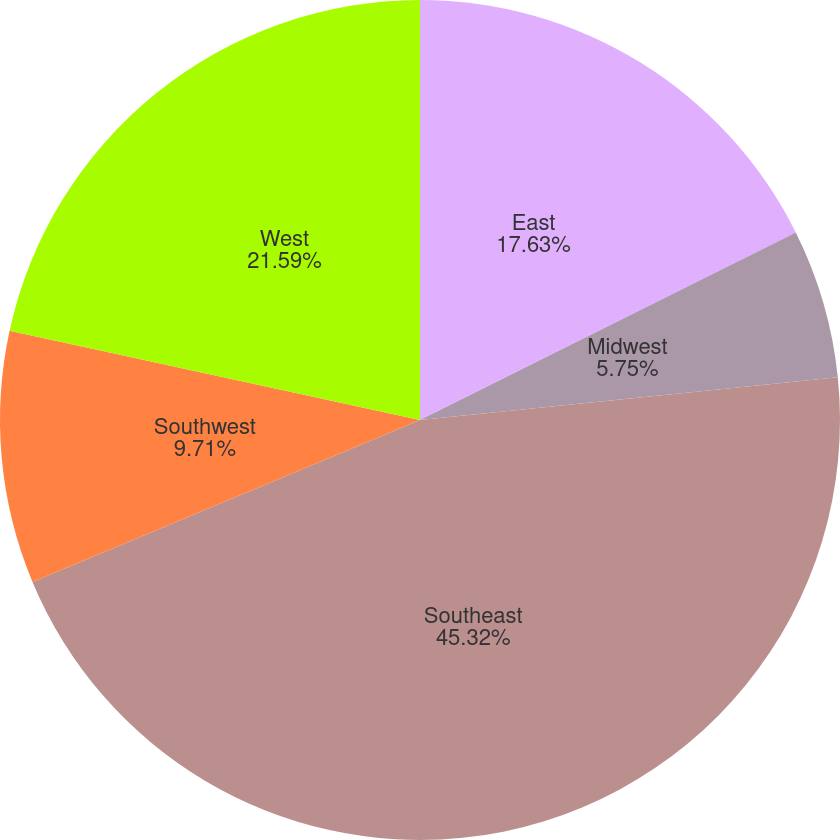<chart> <loc_0><loc_0><loc_500><loc_500><pie_chart><fcel>East<fcel>Midwest<fcel>Southeast<fcel>Southwest<fcel>West<nl><fcel>17.63%<fcel>5.75%<fcel>45.32%<fcel>9.71%<fcel>21.59%<nl></chart> 